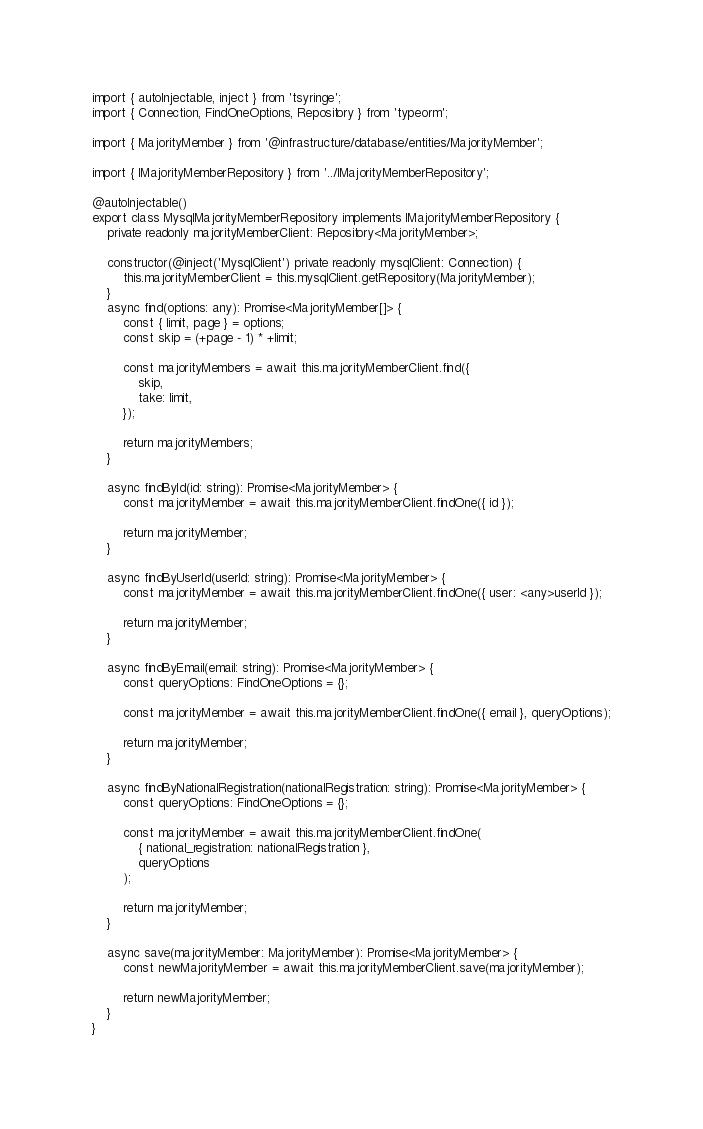<code> <loc_0><loc_0><loc_500><loc_500><_TypeScript_>import { autoInjectable, inject } from 'tsyringe';
import { Connection, FindOneOptions, Repository } from 'typeorm';

import { MajorityMember } from '@infrastructure/database/entities/MajorityMember';

import { IMajorityMemberRepository } from '../IMajorityMemberRepository';

@autoInjectable()
export class MysqlMajorityMemberRepository implements IMajorityMemberRepository {
	private readonly majorityMemberClient: Repository<MajorityMember>;

	constructor(@inject('MysqlClient') private readonly mysqlClient: Connection) {
		this.majorityMemberClient = this.mysqlClient.getRepository(MajorityMember);
	}
	async find(options: any): Promise<MajorityMember[]> {
		const { limit, page } = options;
		const skip = (+page - 1) * +limit;

		const majorityMembers = await this.majorityMemberClient.find({
			skip,
			take: limit,
		});

		return majorityMembers;
	}

	async findById(id: string): Promise<MajorityMember> {
		const majorityMember = await this.majorityMemberClient.findOne({ id });

		return majorityMember;
	}

	async findByUserId(userId: string): Promise<MajorityMember> {
		const majorityMember = await this.majorityMemberClient.findOne({ user: <any>userId });

		return majorityMember;
	}

	async findByEmail(email: string): Promise<MajorityMember> {
		const queryOptions: FindOneOptions = {};

		const majorityMember = await this.majorityMemberClient.findOne({ email }, queryOptions);

		return majorityMember;
	}

	async findByNationalRegistration(nationalRegistration: string): Promise<MajorityMember> {
		const queryOptions: FindOneOptions = {};

		const majorityMember = await this.majorityMemberClient.findOne(
			{ national_registration: nationalRegistration },
			queryOptions
		);

		return majorityMember;
	}

	async save(majorityMember: MajorityMember): Promise<MajorityMember> {
		const newMajorityMember = await this.majorityMemberClient.save(majorityMember);

		return newMajorityMember;
	}
}
</code> 